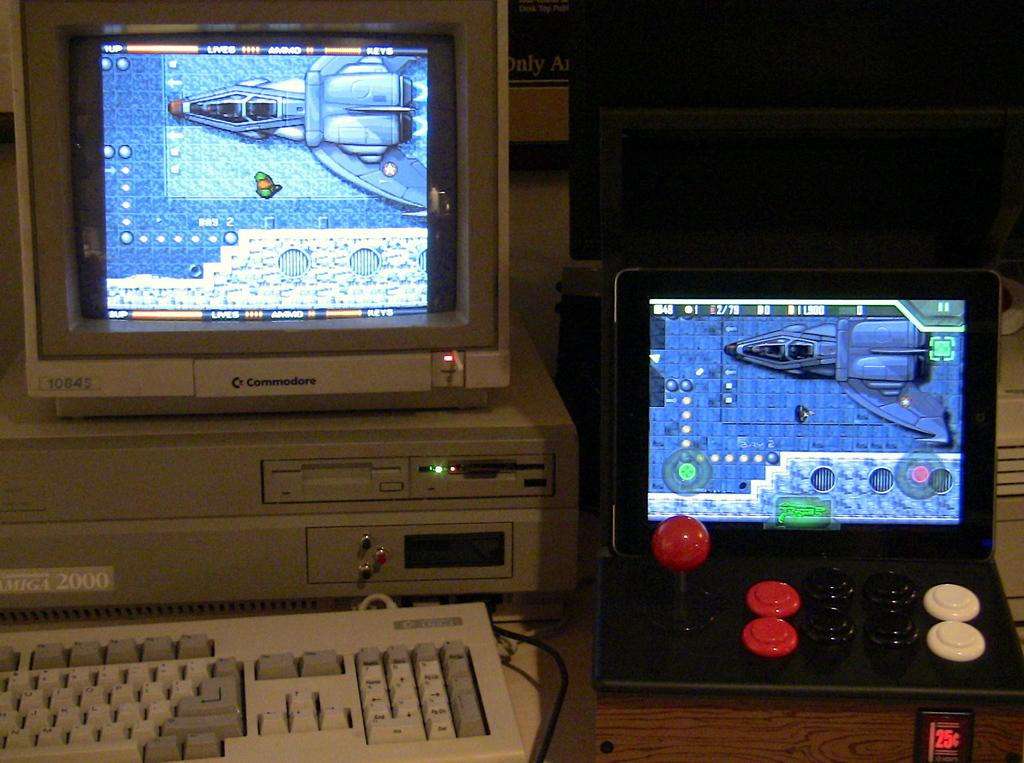<image>
Provide a brief description of the given image. An old commodore branded computer is sitting next to a small arcade like system. 